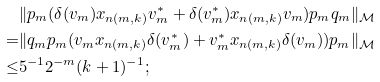Convert formula to latex. <formula><loc_0><loc_0><loc_500><loc_500>& \| p _ { m } ( \delta ( v _ { m } ) x _ { n ( m , k ) } v _ { m } ^ { * } + \delta ( v _ { m } ^ { * } ) x _ { n ( m , k ) } v _ { m } ) p _ { m } q _ { m } \| _ { \mathcal { M } } \\ = & \| q _ { m } p _ { m } ( v _ { m } x _ { n ( m , k ) } \delta ( v _ { m } ^ { * } ) + v _ { m } ^ { * } x _ { n ( m , k ) } \delta ( v _ { m } ) ) p _ { m } \| _ { \mathcal { M } } \\ \leq & 5 ^ { - 1 } 2 ^ { - m } ( k + 1 ) ^ { - 1 } ;</formula> 